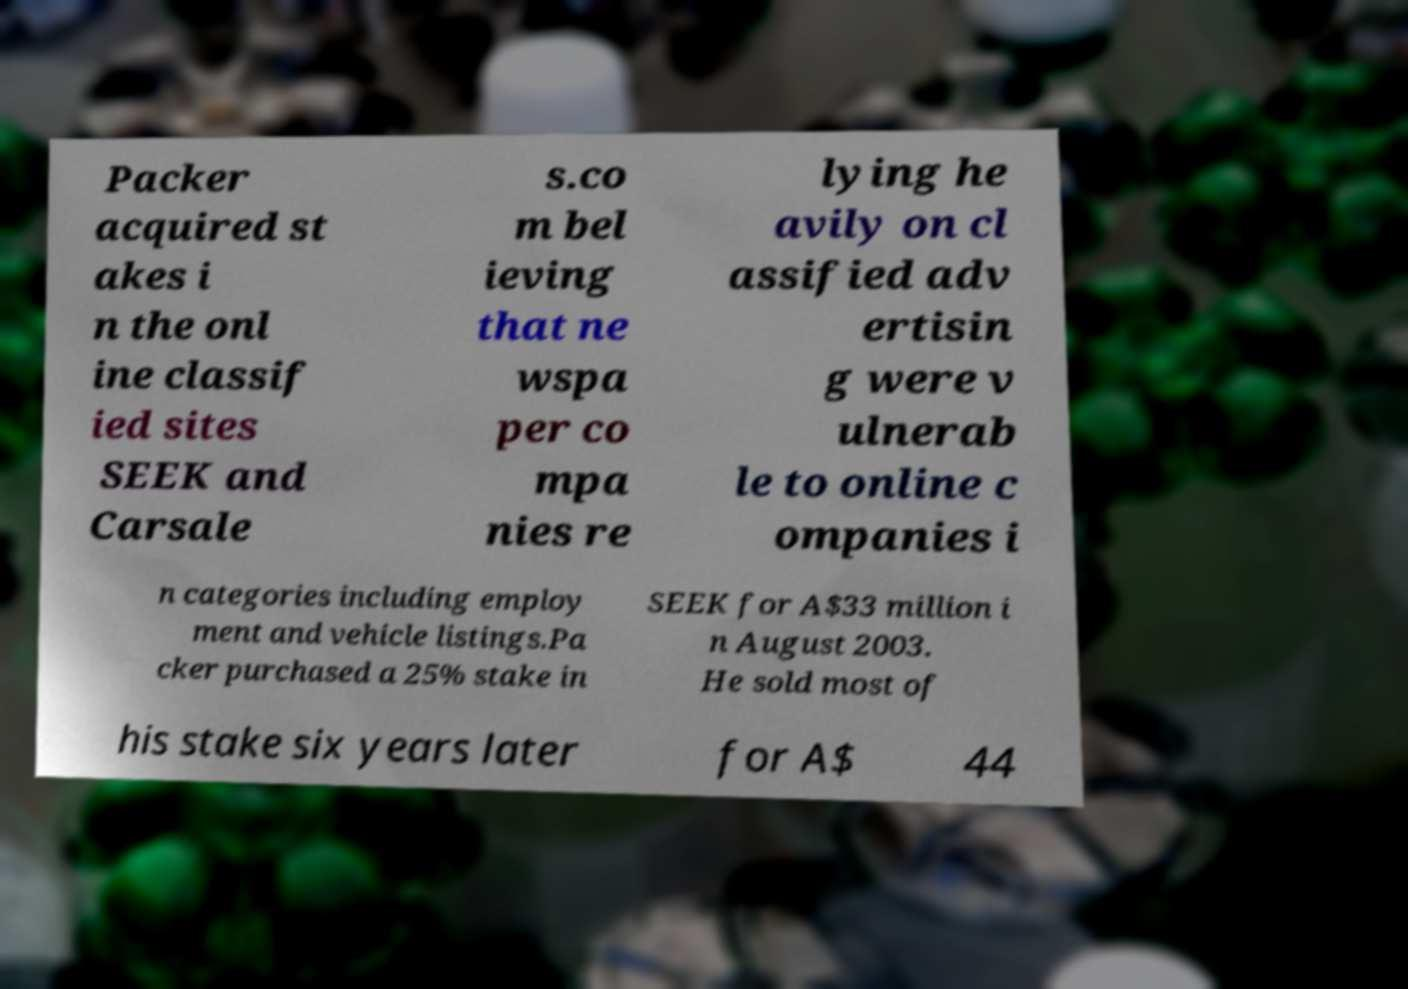For documentation purposes, I need the text within this image transcribed. Could you provide that? Packer acquired st akes i n the onl ine classif ied sites SEEK and Carsale s.co m bel ieving that ne wspa per co mpa nies re lying he avily on cl assified adv ertisin g were v ulnerab le to online c ompanies i n categories including employ ment and vehicle listings.Pa cker purchased a 25% stake in SEEK for A$33 million i n August 2003. He sold most of his stake six years later for A$ 44 